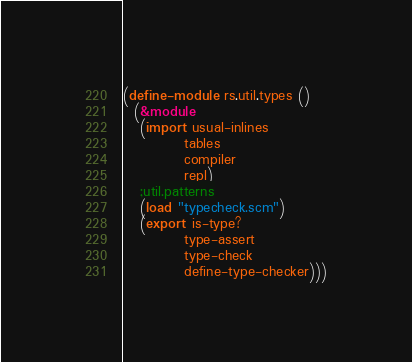<code> <loc_0><loc_0><loc_500><loc_500><_Scheme_>(define-module rs.util.types ()
  (&module
   (import usual-inlines
           tables
           compiler
           repl)
   ;util.patterns
   (load "typecheck.scm")
   (export is-type?
           type-assert
           type-check
           define-type-checker)))
</code> 